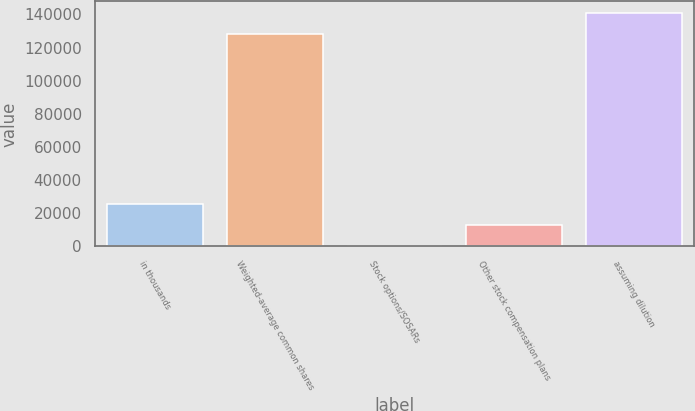Convert chart. <chart><loc_0><loc_0><loc_500><loc_500><bar_chart><fcel>in thousands<fcel>Weighted-average common shares<fcel>Stock options/SOSARs<fcel>Other stock compensation plans<fcel>assuming dilution<nl><fcel>25612.9<fcel>128050<fcel>3.63<fcel>12808.3<fcel>140855<nl></chart> 